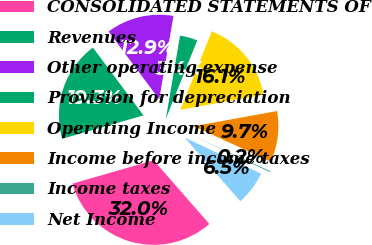Convert chart. <chart><loc_0><loc_0><loc_500><loc_500><pie_chart><fcel>CONSOLIDATED STATEMENTS OF<fcel>Revenues<fcel>Other operating expense<fcel>Provision for depreciation<fcel>Operating Income<fcel>Income before income taxes<fcel>Income taxes<fcel>Net Income<nl><fcel>31.97%<fcel>19.26%<fcel>12.9%<fcel>3.36%<fcel>16.08%<fcel>9.72%<fcel>0.18%<fcel>6.54%<nl></chart> 